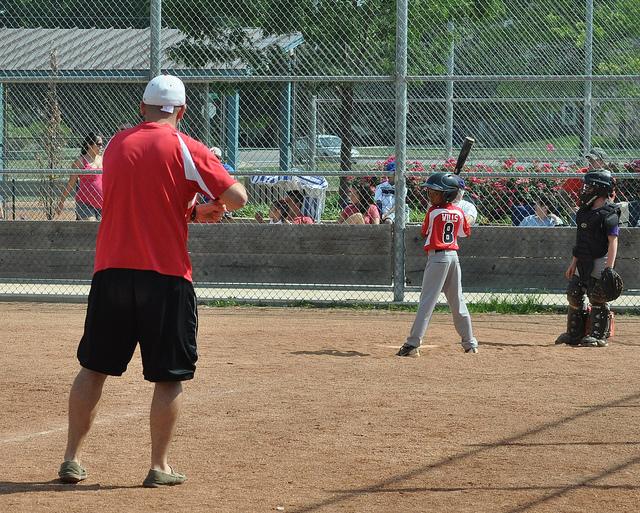What number is the person batting?
Short answer required. 8. Are the players adults or children?
Write a very short answer. Children. What sport are the boys playing?
Answer briefly. Baseball. Is the picture taken at night time?
Answer briefly. No. What color is the catcher's mitt?
Give a very brief answer. Black. Could this be a little league game?
Answer briefly. Yes. 